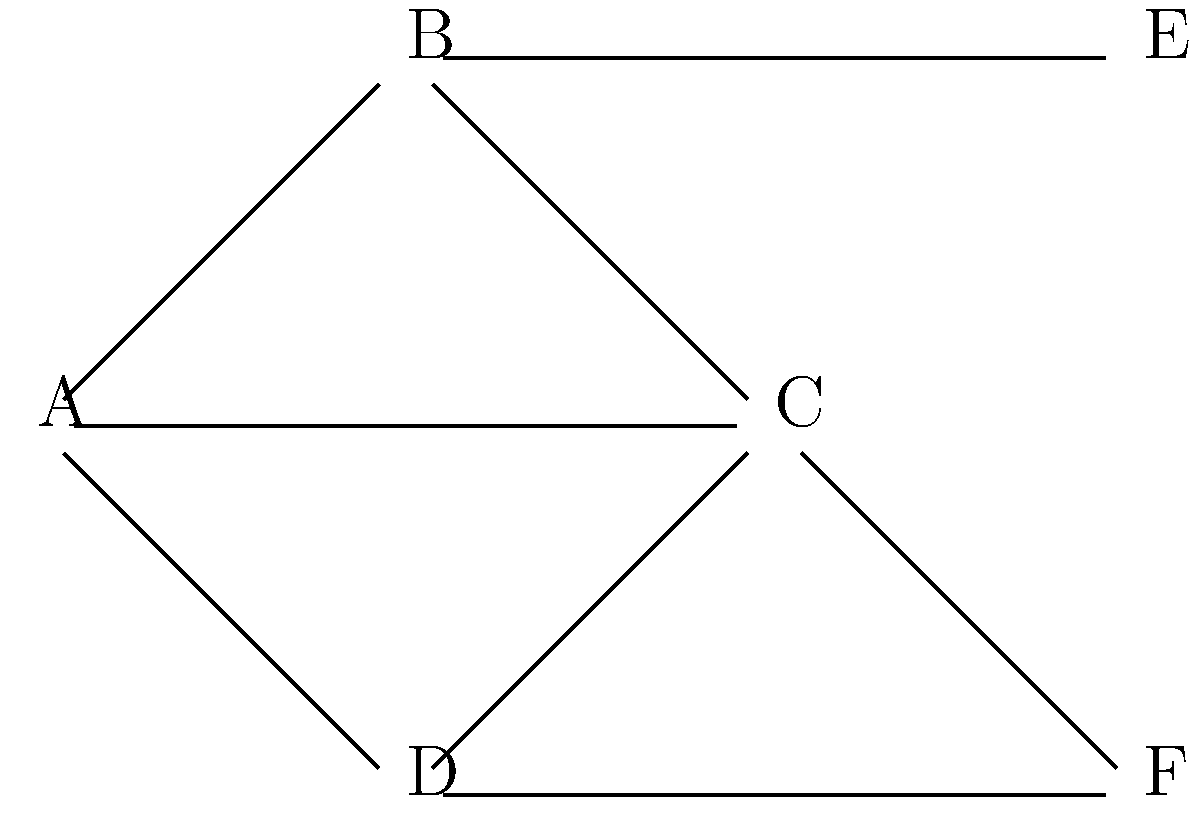In the sociogram above, which individual appears to have the highest degree centrality, and what implications might this have for group dynamics in a therapeutic setting? To answer this question, we need to follow these steps:

1. Understand degree centrality:
   Degree centrality is the number of direct connections an individual has in a network.

2. Count connections for each node:
   A: 3 connections (B, C, D)
   B: 3 connections (A, C, E)
   C: 4 connections (A, B, D, F)
   D: 3 connections (A, C, F)
   E: 1 connection (B)
   F: 2 connections (C, D)

3. Identify the highest degree centrality:
   Node C has the highest degree centrality with 4 connections.

4. Consider implications in a therapeutic setting:
   a) Information flow: C is likely to receive and distribute information quickly.
   b) Influence: C may have significant influence over group opinions and decisions.
   c) Group cohesion: C could act as a bridge between different subgroups.
   d) Therapeutic interventions: The therapist might leverage C's position to facilitate communication or address group-wide issues.
   e) Potential challenges: Over-reliance on C could lead to communication bottlenecks or power imbalances within the group.

5. Synthesize the implications:
   C's high degree centrality suggests they play a crucial role in group dynamics, potentially facilitating communication and cohesion, but also requiring careful management to ensure balanced participation and prevent over-dependence.
Answer: C has the highest degree centrality, implying a central role in group communication and cohesion, which requires careful management in therapy. 